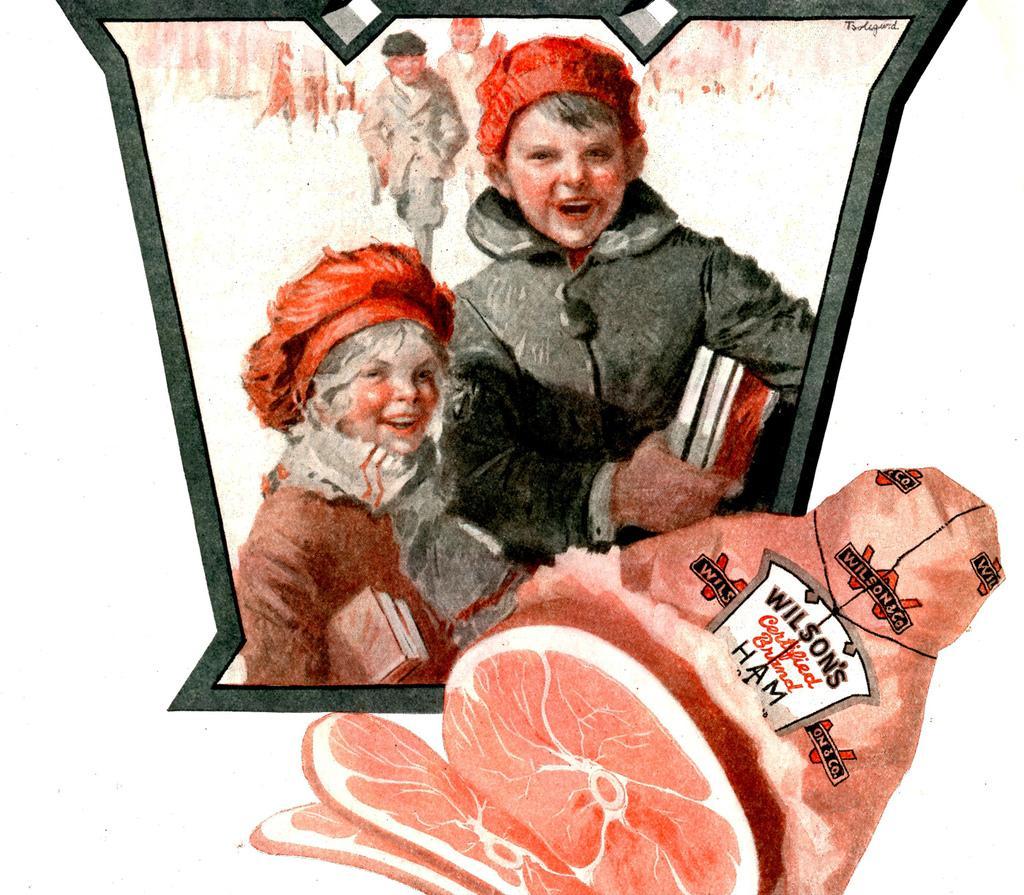How would you summarize this image in a sentence or two? There is a painting in the image. At the bottom right corner of the image there is a meat. And inside the black frame there are two people with red cap and holding the books in their hands. 